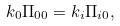Convert formula to latex. <formula><loc_0><loc_0><loc_500><loc_500>k _ { 0 } \Pi _ { 0 0 } = k _ { i } \Pi _ { i 0 } ,</formula> 